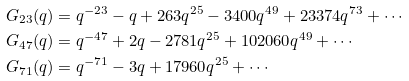<formula> <loc_0><loc_0><loc_500><loc_500>G _ { 2 3 } ( q ) & = q ^ { - 2 3 } - q + 2 6 3 q ^ { 2 5 } - 3 4 0 0 q ^ { 4 9 } + 2 3 3 7 4 q ^ { 7 3 } + \cdots \\ G _ { 4 7 } ( q ) & = q ^ { - 4 7 } + 2 q - 2 7 8 1 q ^ { 2 5 } + 1 0 2 0 6 0 q ^ { 4 9 } + \cdots \\ G _ { 7 1 } ( q ) & = q ^ { - 7 1 } - 3 q + 1 7 9 6 0 q ^ { 2 5 } + \cdots \\</formula> 